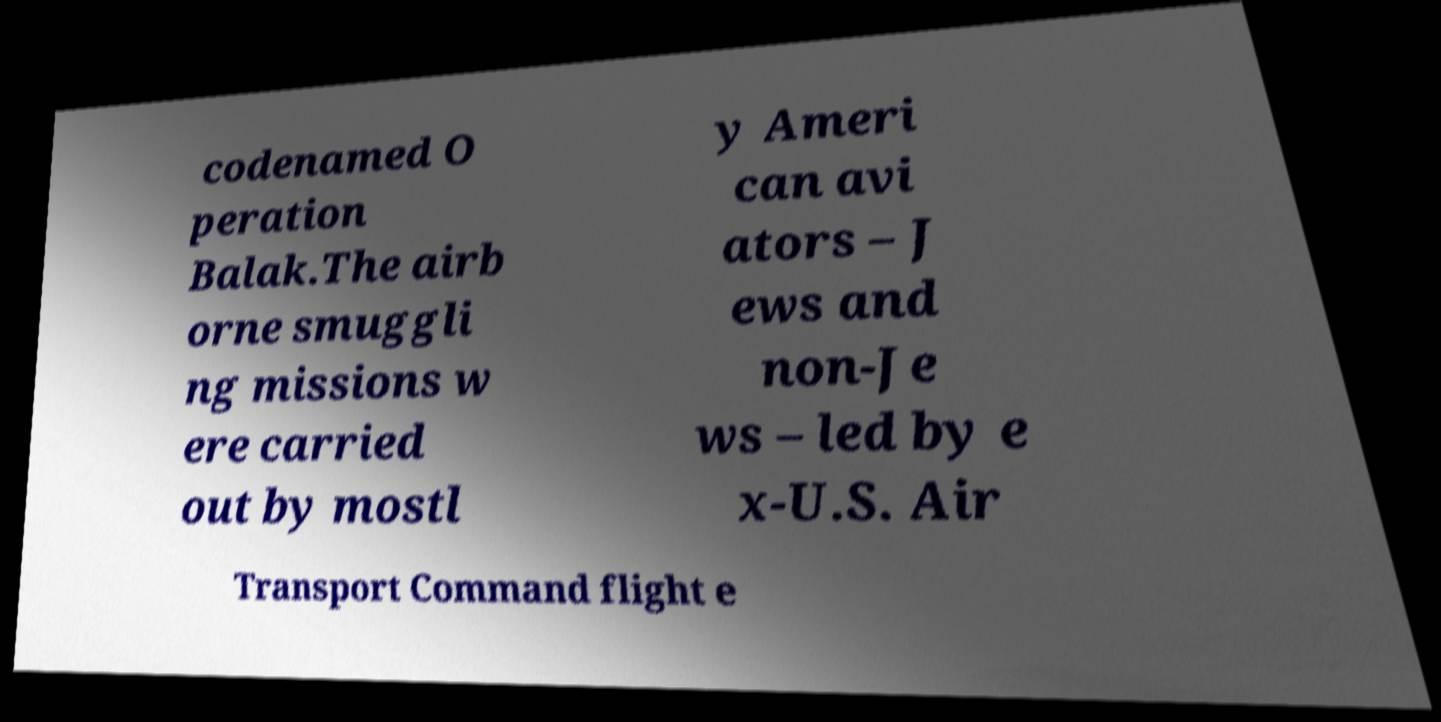Please read and relay the text visible in this image. What does it say? codenamed O peration Balak.The airb orne smuggli ng missions w ere carried out by mostl y Ameri can avi ators – J ews and non-Je ws – led by e x-U.S. Air Transport Command flight e 